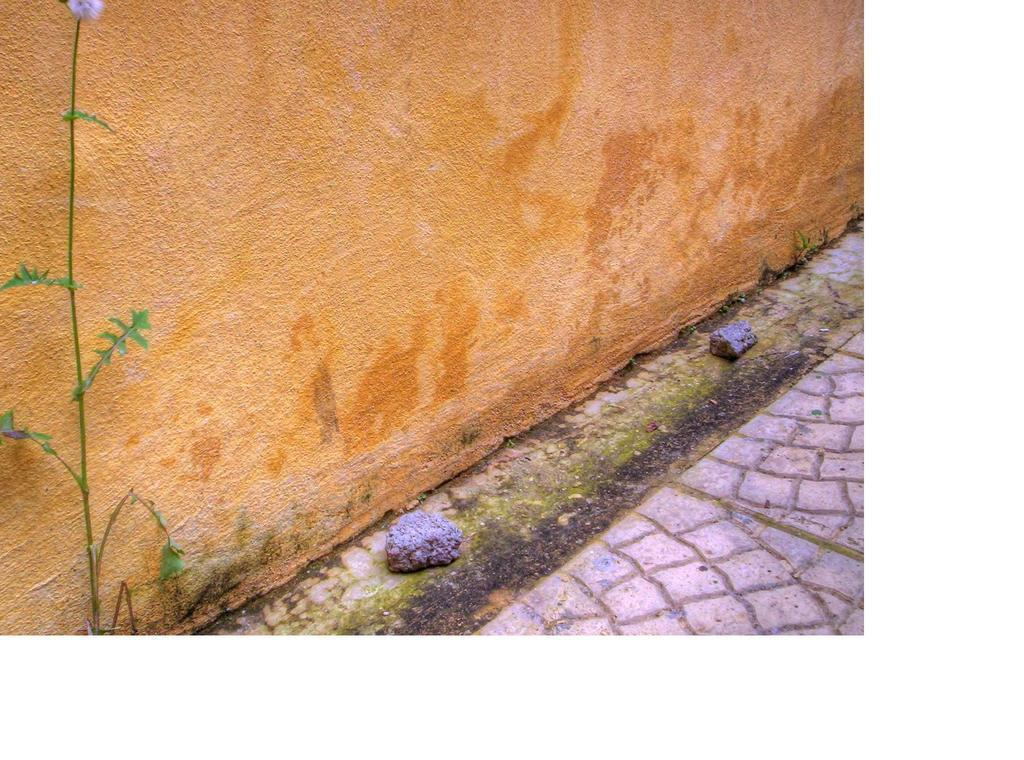What type of vegetation is on the left side of the image? There is a plant on the left side of the image. What structure is located in the middle of the image? There is a wall in the middle of the image. What type of material is covering the floor at the bottom of the image? There are stones on the floor at the bottom of the image. Can you tell me how many kitties are sitting on the wall in the image? There are no kitties present in the image; it only features a plant, a wall, and stones on the floor. What is the cause of the plant's growth in the image? The image does not provide information about the cause of the plant's growth; it only shows the plant's presence. 